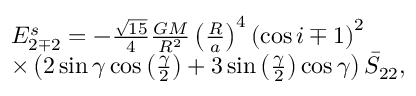<formula> <loc_0><loc_0><loc_500><loc_500>\begin{array} { r l } & { E _ { 2 \mp 2 } ^ { s } = - \frac { \sqrt { 1 5 } } { 4 } \frac { G M } { R ^ { 2 } } \left ( \frac { R } { a } \right ) ^ { 4 } \left ( \cos i \mp 1 \right ) ^ { 2 } } \\ & { \times \left ( 2 \sin \gamma \cos \left ( \frac { \gamma } { 2 } \right ) + 3 \sin \left ( \frac { \gamma } { 2 } \right ) \cos \gamma \right ) \bar { S } _ { 2 2 } , } \end{array}</formula> 